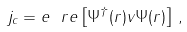<formula> <loc_0><loc_0><loc_500><loc_500>j _ { c } = e \ r e \left [ \Psi ^ { \dag } ( r ) v \Psi ( r ) \right ] \, ,</formula> 